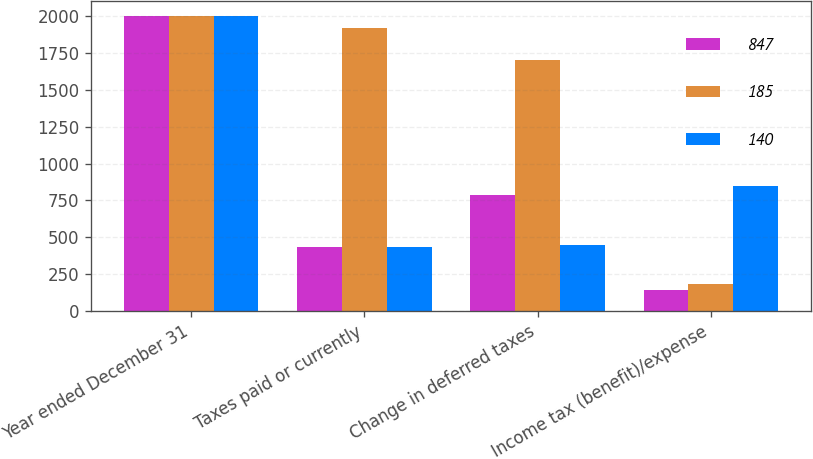<chart> <loc_0><loc_0><loc_500><loc_500><stacked_bar_chart><ecel><fcel>Year ended December 31<fcel>Taxes paid or currently<fcel>Change in deferred taxes<fcel>Income tax (benefit)/expense<nl><fcel>847<fcel>2004<fcel>435<fcel>787<fcel>140<nl><fcel>185<fcel>2003<fcel>1923<fcel>1707<fcel>185<nl><fcel>140<fcel>2002<fcel>432<fcel>449<fcel>847<nl></chart> 